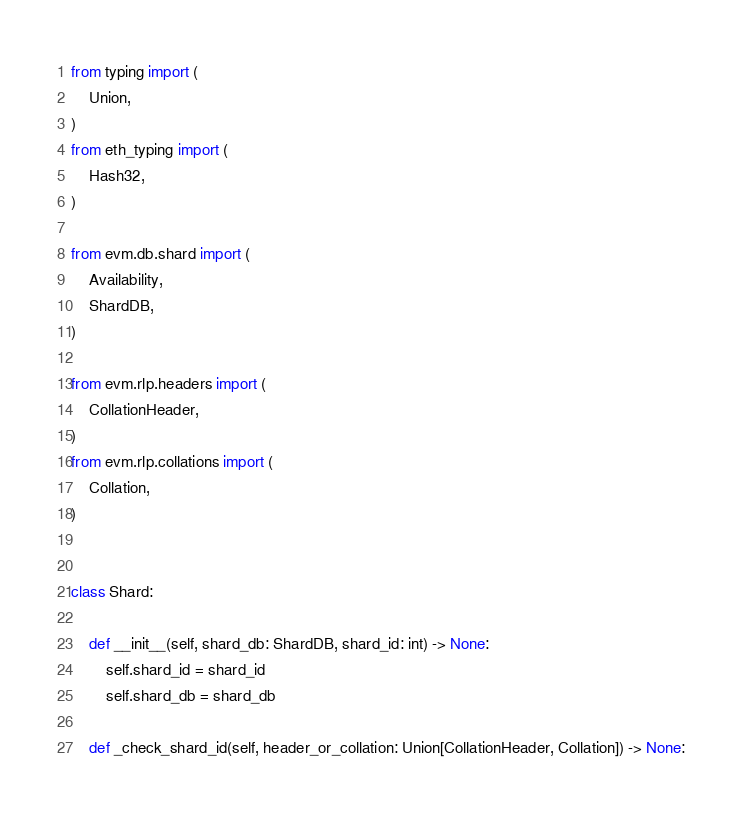Convert code to text. <code><loc_0><loc_0><loc_500><loc_500><_Python_>from typing import (
    Union,
)
from eth_typing import (
    Hash32,
)

from evm.db.shard import (
    Availability,
    ShardDB,
)

from evm.rlp.headers import (
    CollationHeader,
)
from evm.rlp.collations import (
    Collation,
)


class Shard:

    def __init__(self, shard_db: ShardDB, shard_id: int) -> None:
        self.shard_id = shard_id
        self.shard_db = shard_db

    def _check_shard_id(self, header_or_collation: Union[CollationHeader, Collation]) -> None:</code> 